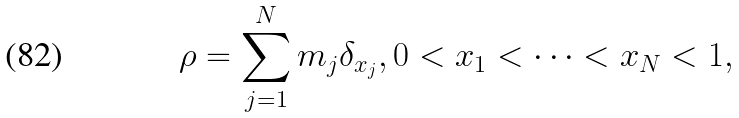Convert formula to latex. <formula><loc_0><loc_0><loc_500><loc_500>\rho = \sum _ { j = 1 } ^ { N } m _ { j } \delta _ { x _ { j } } , 0 < x _ { 1 } < \dots < x _ { N } < 1 ,</formula> 